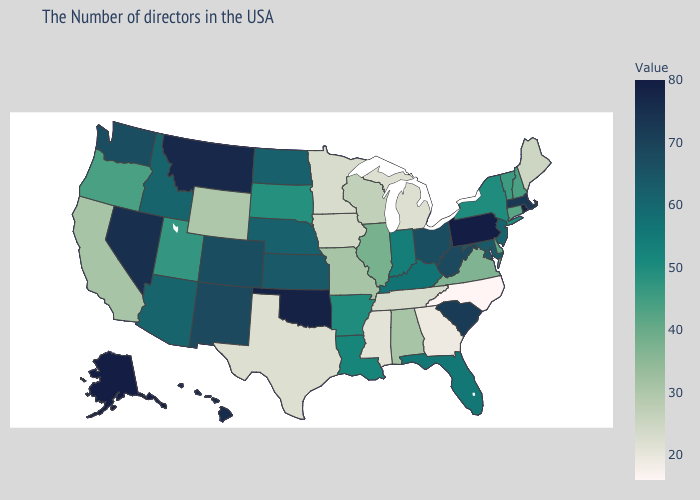Does North Carolina have the lowest value in the USA?
Concise answer only. Yes. Which states have the lowest value in the Northeast?
Short answer required. Maine. Is the legend a continuous bar?
Give a very brief answer. Yes. Among the states that border Nebraska , does Iowa have the lowest value?
Give a very brief answer. Yes. Among the states that border Arizona , which have the lowest value?
Write a very short answer. California. Which states have the lowest value in the West?
Short answer required. Wyoming. Does North Carolina have the lowest value in the USA?
Be succinct. Yes. 